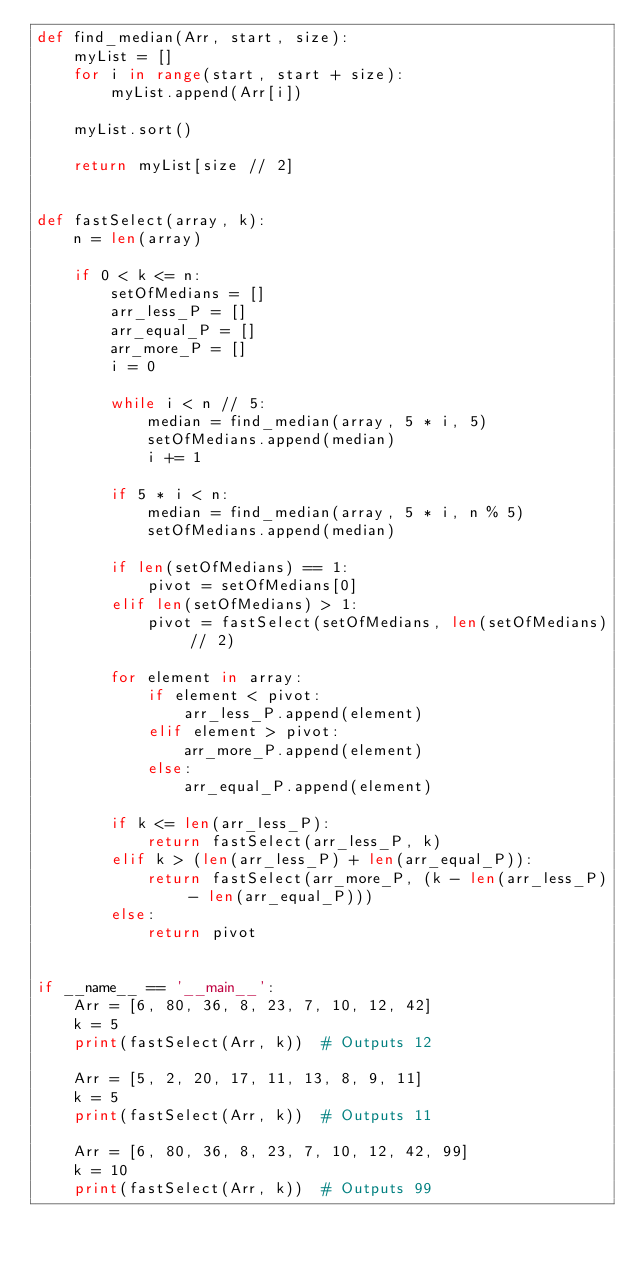<code> <loc_0><loc_0><loc_500><loc_500><_Python_>def find_median(Arr, start, size):
    myList = []
    for i in range(start, start + size):
        myList.append(Arr[i])

    myList.sort()

    return myList[size // 2]


def fastSelect(array, k):
    n = len(array)

    if 0 < k <= n:
        setOfMedians = []
        arr_less_P = []
        arr_equal_P = []
        arr_more_P = []
        i = 0

        while i < n // 5:
            median = find_median(array, 5 * i, 5)
            setOfMedians.append(median)
            i += 1

        if 5 * i < n:
            median = find_median(array, 5 * i, n % 5)
            setOfMedians.append(median)

        if len(setOfMedians) == 1:
            pivot = setOfMedians[0]
        elif len(setOfMedians) > 1:
            pivot = fastSelect(setOfMedians, len(setOfMedians) // 2)

        for element in array:
            if element < pivot:
                arr_less_P.append(element)
            elif element > pivot:
                arr_more_P.append(element)
            else:
                arr_equal_P.append(element)

        if k <= len(arr_less_P):
            return fastSelect(arr_less_P, k)
        elif k > (len(arr_less_P) + len(arr_equal_P)):
            return fastSelect(arr_more_P, (k - len(arr_less_P) - len(arr_equal_P)))
        else:
            return pivot


if __name__ == '__main__':
    Arr = [6, 80, 36, 8, 23, 7, 10, 12, 42]
    k = 5
    print(fastSelect(Arr, k))  # Outputs 12

    Arr = [5, 2, 20, 17, 11, 13, 8, 9, 11]
    k = 5
    print(fastSelect(Arr, k))  # Outputs 11

    Arr = [6, 80, 36, 8, 23, 7, 10, 12, 42, 99]
    k = 10
    print(fastSelect(Arr, k))  # Outputs 99
</code> 